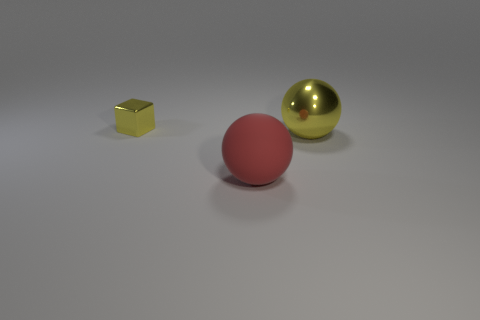What material is the yellow thing that is behind the shiny thing to the right of the red matte object on the right side of the tiny thing?
Your answer should be very brief. Metal. Are there any small yellow things made of the same material as the big red object?
Give a very brief answer. No. Do the yellow cube and the big yellow thing have the same material?
Your response must be concise. Yes. What number of cubes are red things or tiny things?
Give a very brief answer. 1. What color is the object that is the same material as the tiny block?
Make the answer very short. Yellow. Is the number of small yellow objects less than the number of purple metallic things?
Your answer should be very brief. No. Does the yellow metallic object to the right of the small cube have the same shape as the yellow thing to the left of the red matte sphere?
Your answer should be compact. No. How many objects are big metal spheres or purple matte spheres?
Your response must be concise. 1. There is another sphere that is the same size as the rubber ball; what color is it?
Offer a very short reply. Yellow. There is a yellow metallic thing on the left side of the big red rubber thing; what number of tiny yellow metal blocks are in front of it?
Ensure brevity in your answer.  0. 